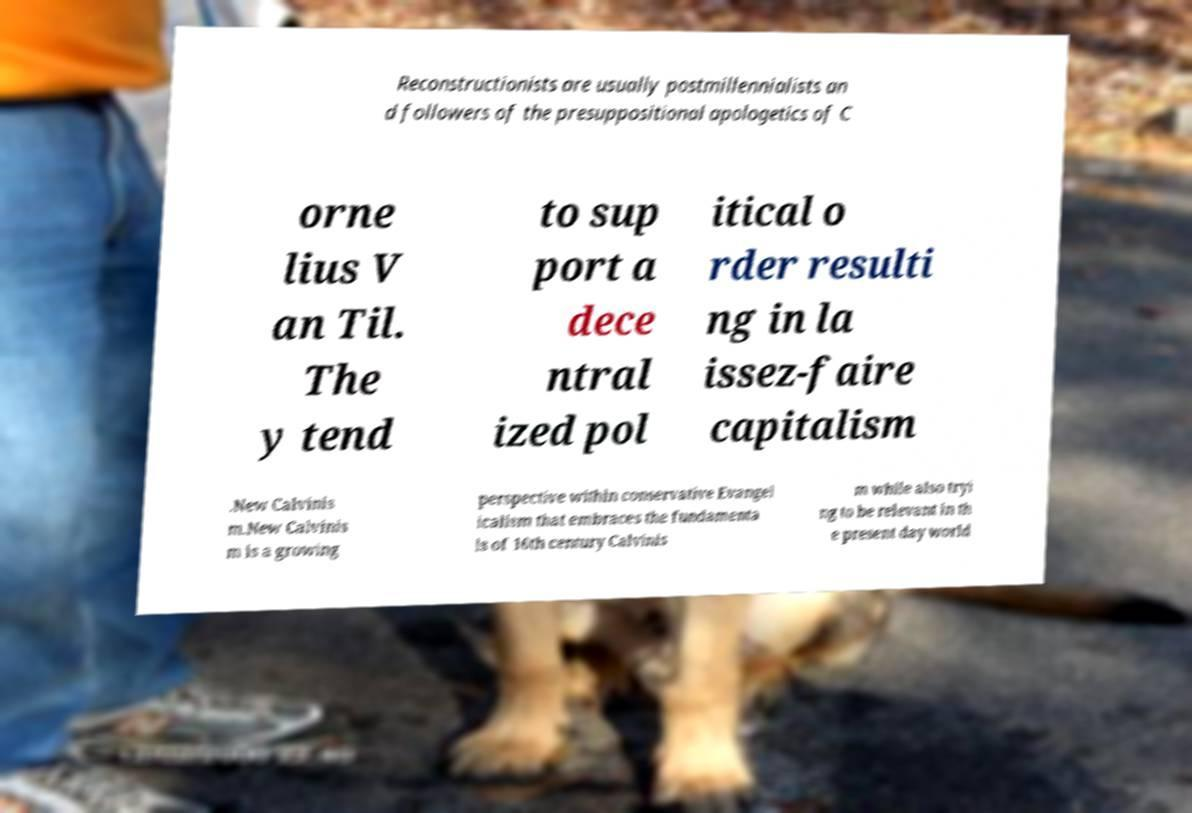Could you extract and type out the text from this image? Reconstructionists are usually postmillennialists an d followers of the presuppositional apologetics of C orne lius V an Til. The y tend to sup port a dece ntral ized pol itical o rder resulti ng in la issez-faire capitalism .New Calvinis m.New Calvinis m is a growing perspective within conservative Evangel icalism that embraces the fundamenta ls of 16th century Calvinis m while also tryi ng to be relevant in th e present day world 